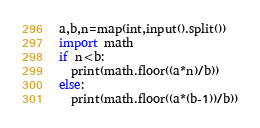<code> <loc_0><loc_0><loc_500><loc_500><_Python_>a,b,n=map(int,input().split())
import math
if n<b:
  print(math.floor((a*n)/b))
else:
  print(math.floor((a*(b-1))/b))</code> 